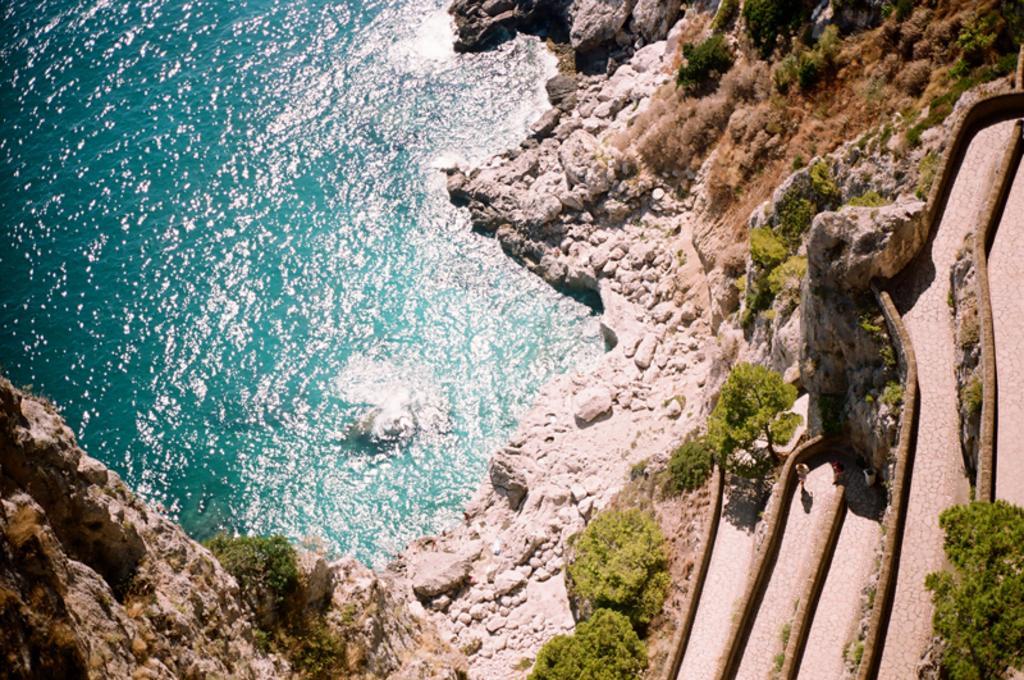Could you give a brief overview of what you see in this image? We can see in the image, the water is floating. Beside water, there are some rocks and in some places there is a grass. 